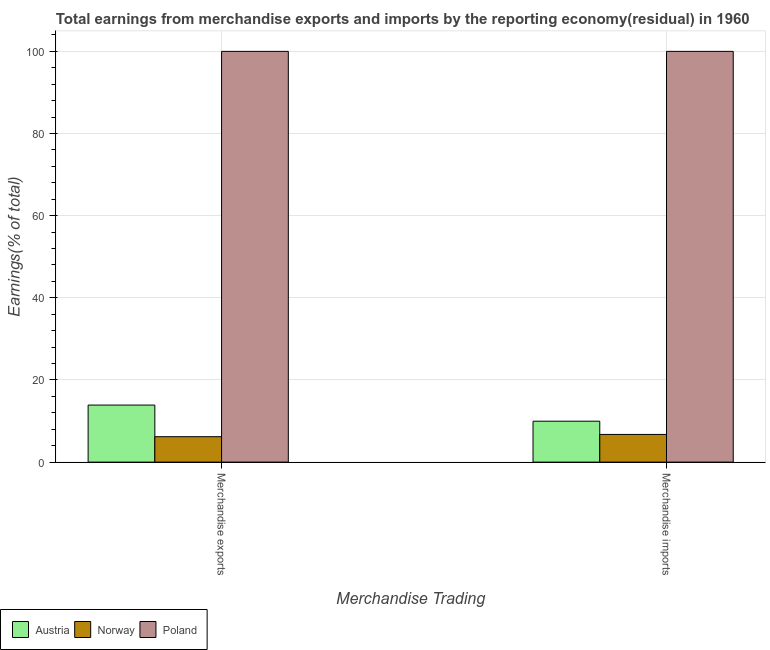How many different coloured bars are there?
Your answer should be compact. 3. How many bars are there on the 1st tick from the left?
Your answer should be very brief. 3. What is the earnings from merchandise imports in Austria?
Keep it short and to the point. 9.97. Across all countries, what is the maximum earnings from merchandise exports?
Provide a short and direct response. 100. Across all countries, what is the minimum earnings from merchandise imports?
Your answer should be very brief. 6.74. In which country was the earnings from merchandise exports maximum?
Keep it short and to the point. Poland. In which country was the earnings from merchandise imports minimum?
Ensure brevity in your answer.  Norway. What is the total earnings from merchandise imports in the graph?
Your response must be concise. 116.71. What is the difference between the earnings from merchandise imports in Norway and that in Poland?
Offer a terse response. -93.26. What is the difference between the earnings from merchandise imports in Austria and the earnings from merchandise exports in Poland?
Keep it short and to the point. -90.03. What is the average earnings from merchandise imports per country?
Your answer should be very brief. 38.9. What is the ratio of the earnings from merchandise imports in Poland to that in Austria?
Your answer should be compact. 10.03. Is the earnings from merchandise imports in Norway less than that in Austria?
Offer a very short reply. Yes. In how many countries, is the earnings from merchandise imports greater than the average earnings from merchandise imports taken over all countries?
Provide a short and direct response. 1. What does the 2nd bar from the right in Merchandise imports represents?
Your answer should be very brief. Norway. How many bars are there?
Ensure brevity in your answer.  6. Are all the bars in the graph horizontal?
Your response must be concise. No. What is the difference between two consecutive major ticks on the Y-axis?
Your answer should be very brief. 20. Does the graph contain any zero values?
Your answer should be very brief. No. Does the graph contain grids?
Your response must be concise. Yes. How are the legend labels stacked?
Offer a terse response. Horizontal. What is the title of the graph?
Give a very brief answer. Total earnings from merchandise exports and imports by the reporting economy(residual) in 1960. Does "Least developed countries" appear as one of the legend labels in the graph?
Ensure brevity in your answer.  No. What is the label or title of the X-axis?
Your response must be concise. Merchandise Trading. What is the label or title of the Y-axis?
Keep it short and to the point. Earnings(% of total). What is the Earnings(% of total) of Austria in Merchandise exports?
Keep it short and to the point. 13.89. What is the Earnings(% of total) of Norway in Merchandise exports?
Offer a very short reply. 6.19. What is the Earnings(% of total) of Poland in Merchandise exports?
Your answer should be very brief. 100. What is the Earnings(% of total) in Austria in Merchandise imports?
Give a very brief answer. 9.97. What is the Earnings(% of total) of Norway in Merchandise imports?
Your response must be concise. 6.74. What is the Earnings(% of total) of Poland in Merchandise imports?
Your answer should be very brief. 100. Across all Merchandise Trading, what is the maximum Earnings(% of total) in Austria?
Give a very brief answer. 13.89. Across all Merchandise Trading, what is the maximum Earnings(% of total) in Norway?
Offer a terse response. 6.74. Across all Merchandise Trading, what is the minimum Earnings(% of total) in Austria?
Make the answer very short. 9.97. Across all Merchandise Trading, what is the minimum Earnings(% of total) in Norway?
Offer a terse response. 6.19. What is the total Earnings(% of total) of Austria in the graph?
Provide a short and direct response. 23.85. What is the total Earnings(% of total) in Norway in the graph?
Offer a terse response. 12.93. What is the difference between the Earnings(% of total) of Austria in Merchandise exports and that in Merchandise imports?
Your answer should be very brief. 3.92. What is the difference between the Earnings(% of total) of Norway in Merchandise exports and that in Merchandise imports?
Provide a succinct answer. -0.55. What is the difference between the Earnings(% of total) in Austria in Merchandise exports and the Earnings(% of total) in Norway in Merchandise imports?
Provide a short and direct response. 7.15. What is the difference between the Earnings(% of total) of Austria in Merchandise exports and the Earnings(% of total) of Poland in Merchandise imports?
Offer a very short reply. -86.11. What is the difference between the Earnings(% of total) in Norway in Merchandise exports and the Earnings(% of total) in Poland in Merchandise imports?
Ensure brevity in your answer.  -93.81. What is the average Earnings(% of total) in Austria per Merchandise Trading?
Your answer should be very brief. 11.93. What is the average Earnings(% of total) in Norway per Merchandise Trading?
Ensure brevity in your answer.  6.47. What is the average Earnings(% of total) of Poland per Merchandise Trading?
Your answer should be compact. 100. What is the difference between the Earnings(% of total) in Austria and Earnings(% of total) in Norway in Merchandise exports?
Provide a succinct answer. 7.7. What is the difference between the Earnings(% of total) of Austria and Earnings(% of total) of Poland in Merchandise exports?
Give a very brief answer. -86.11. What is the difference between the Earnings(% of total) in Norway and Earnings(% of total) in Poland in Merchandise exports?
Provide a short and direct response. -93.81. What is the difference between the Earnings(% of total) of Austria and Earnings(% of total) of Norway in Merchandise imports?
Make the answer very short. 3.23. What is the difference between the Earnings(% of total) of Austria and Earnings(% of total) of Poland in Merchandise imports?
Your response must be concise. -90.03. What is the difference between the Earnings(% of total) of Norway and Earnings(% of total) of Poland in Merchandise imports?
Keep it short and to the point. -93.26. What is the ratio of the Earnings(% of total) in Austria in Merchandise exports to that in Merchandise imports?
Your response must be concise. 1.39. What is the ratio of the Earnings(% of total) in Norway in Merchandise exports to that in Merchandise imports?
Your response must be concise. 0.92. What is the ratio of the Earnings(% of total) of Poland in Merchandise exports to that in Merchandise imports?
Your answer should be very brief. 1. What is the difference between the highest and the second highest Earnings(% of total) in Austria?
Your answer should be compact. 3.92. What is the difference between the highest and the second highest Earnings(% of total) of Norway?
Your answer should be very brief. 0.55. What is the difference between the highest and the second highest Earnings(% of total) of Poland?
Make the answer very short. 0. What is the difference between the highest and the lowest Earnings(% of total) of Austria?
Provide a succinct answer. 3.92. What is the difference between the highest and the lowest Earnings(% of total) in Norway?
Ensure brevity in your answer.  0.55. 